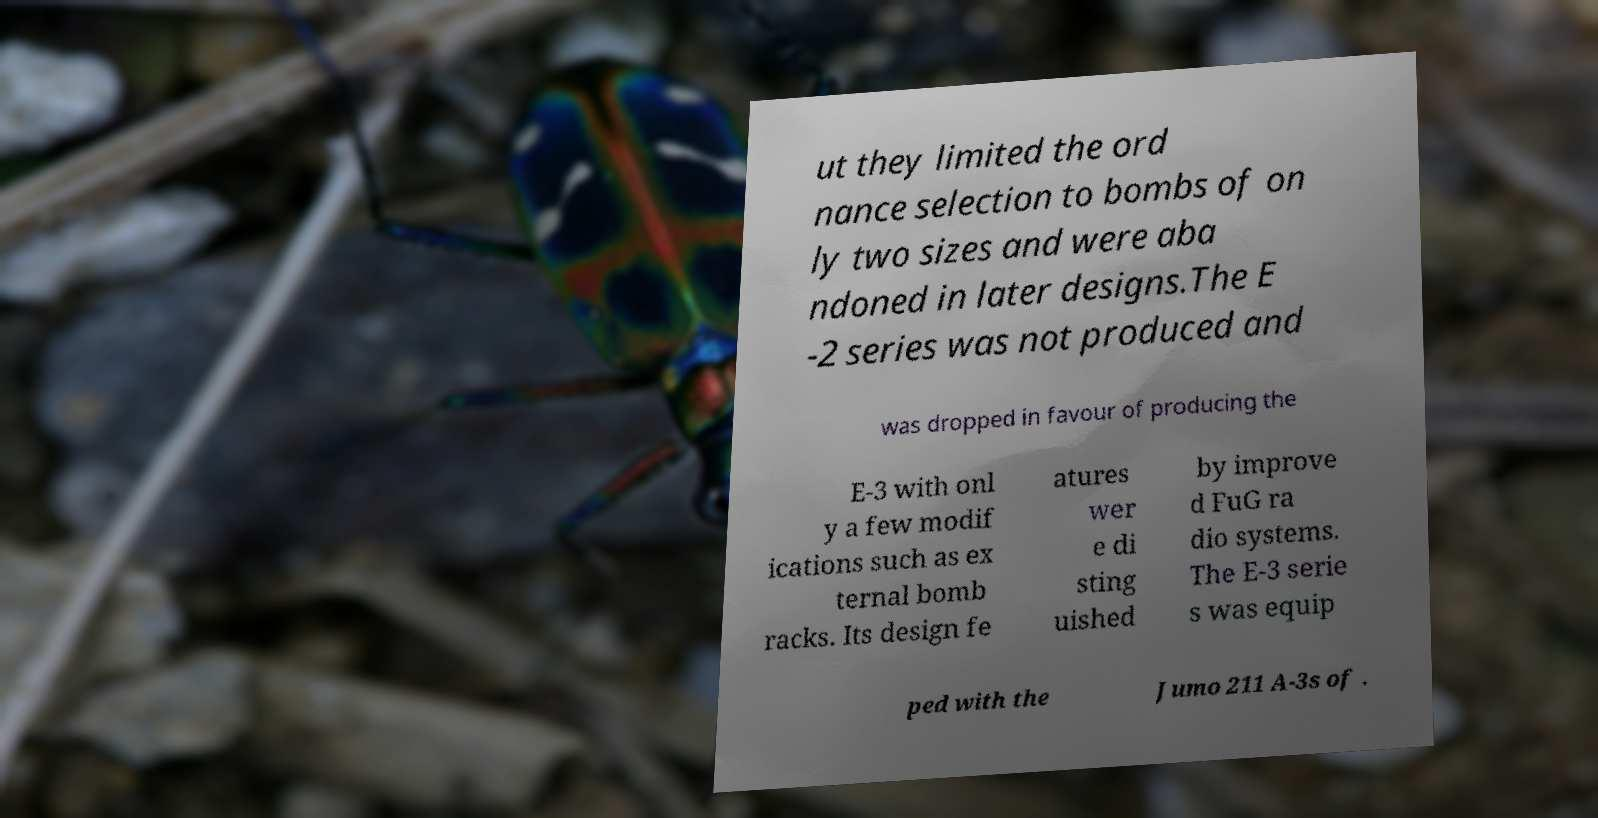Can you read and provide the text displayed in the image?This photo seems to have some interesting text. Can you extract and type it out for me? ut they limited the ord nance selection to bombs of on ly two sizes and were aba ndoned in later designs.The E -2 series was not produced and was dropped in favour of producing the E-3 with onl y a few modif ications such as ex ternal bomb racks. Its design fe atures wer e di sting uished by improve d FuG ra dio systems. The E-3 serie s was equip ped with the Jumo 211 A-3s of . 